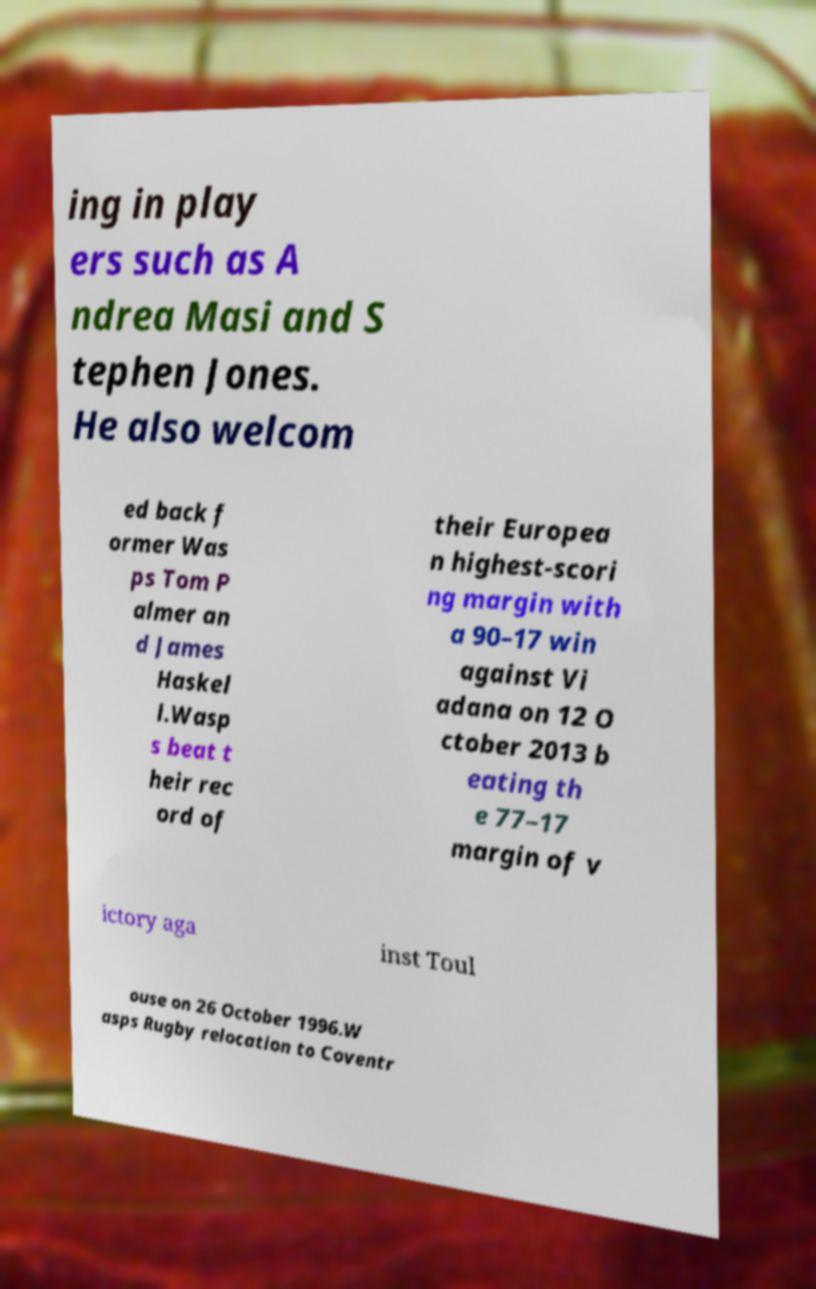Please read and relay the text visible in this image. What does it say? ing in play ers such as A ndrea Masi and S tephen Jones. He also welcom ed back f ormer Was ps Tom P almer an d James Haskel l.Wasp s beat t heir rec ord of their Europea n highest-scori ng margin with a 90–17 win against Vi adana on 12 O ctober 2013 b eating th e 77–17 margin of v ictory aga inst Toul ouse on 26 October 1996.W asps Rugby relocation to Coventr 